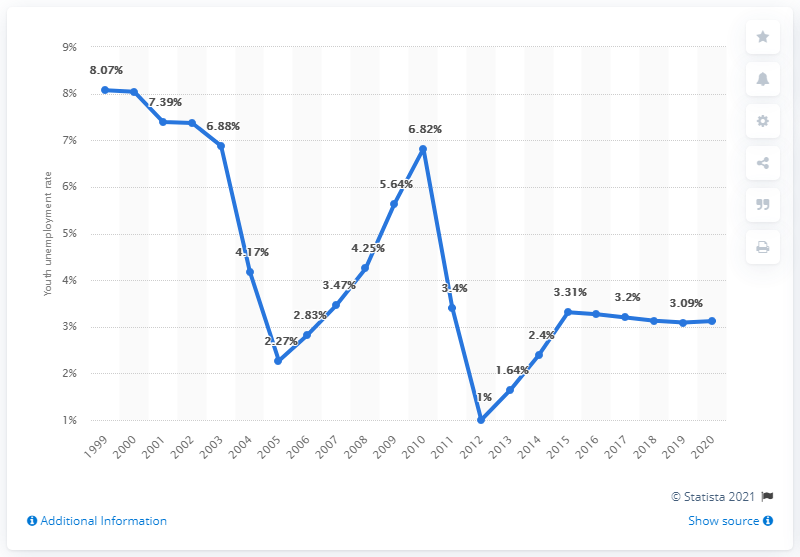Point out several critical features in this image. In 2020, the youth unemployment rate in Madagascar was reported to be 3.12%. 